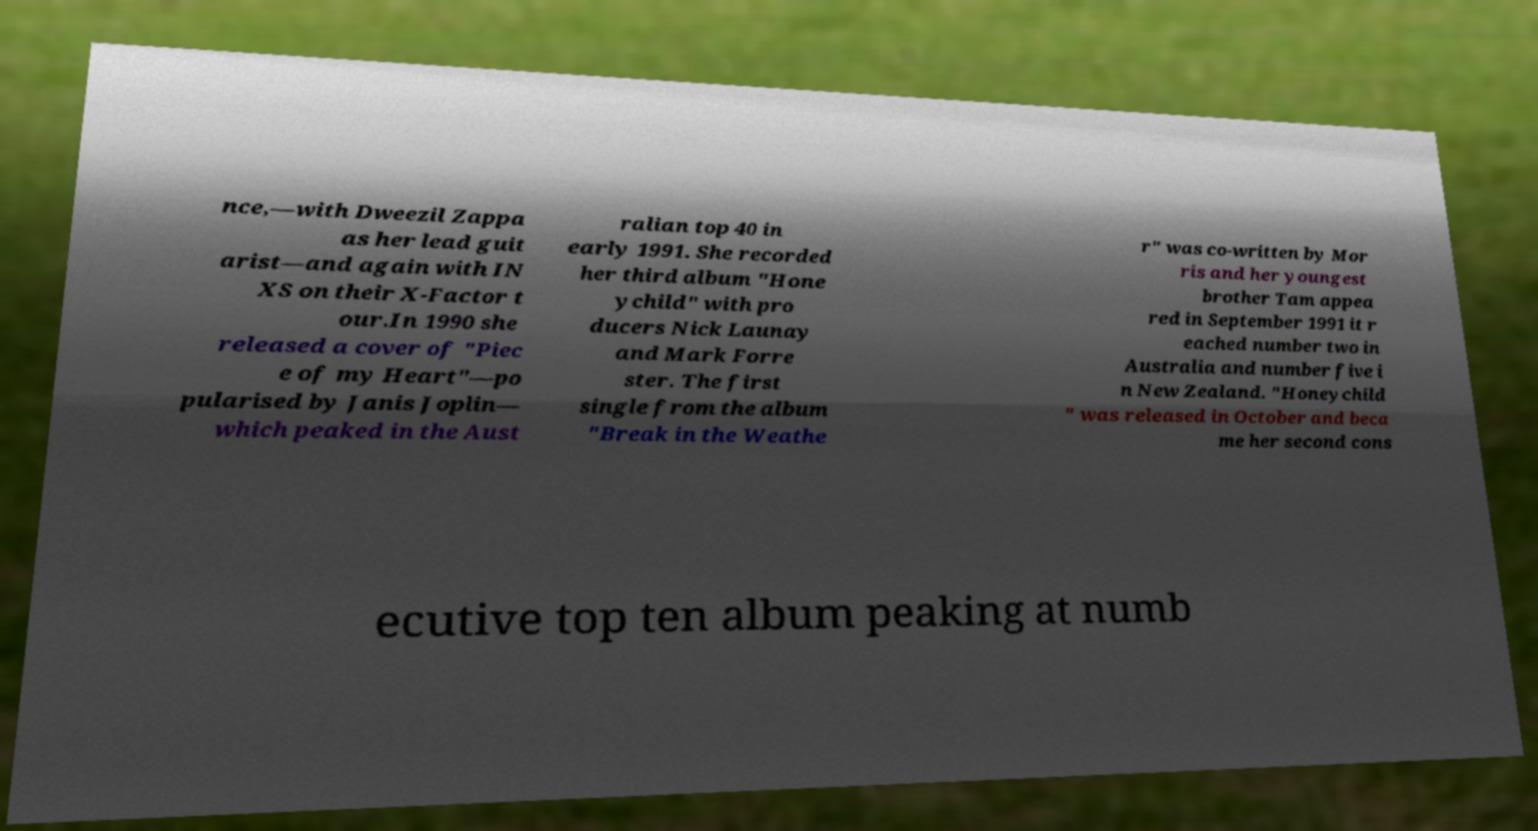For documentation purposes, I need the text within this image transcribed. Could you provide that? nce,—with Dweezil Zappa as her lead guit arist—and again with IN XS on their X-Factor t our.In 1990 she released a cover of "Piec e of my Heart"—po pularised by Janis Joplin— which peaked in the Aust ralian top 40 in early 1991. She recorded her third album "Hone ychild" with pro ducers Nick Launay and Mark Forre ster. The first single from the album "Break in the Weathe r" was co-written by Mor ris and her youngest brother Tam appea red in September 1991 it r eached number two in Australia and number five i n New Zealand. "Honeychild " was released in October and beca me her second cons ecutive top ten album peaking at numb 